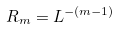Convert formula to latex. <formula><loc_0><loc_0><loc_500><loc_500>R _ { m } = L ^ { - ( m - 1 ) }</formula> 